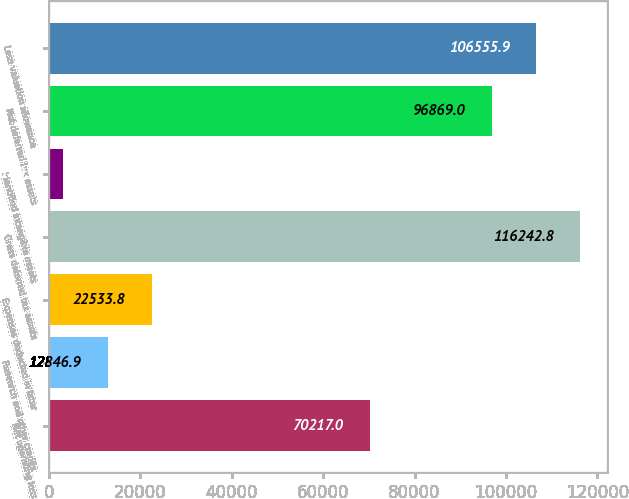Convert chart. <chart><loc_0><loc_0><loc_500><loc_500><bar_chart><fcel>Net operating loss<fcel>Research and other credits<fcel>Expenses deducted in later<fcel>Gross deferred tax assets<fcel>Identified intangible assets<fcel>Net deferred tax assets<fcel>Less valuation allowance<nl><fcel>70217<fcel>12846.9<fcel>22533.8<fcel>116243<fcel>3160<fcel>96869<fcel>106556<nl></chart> 